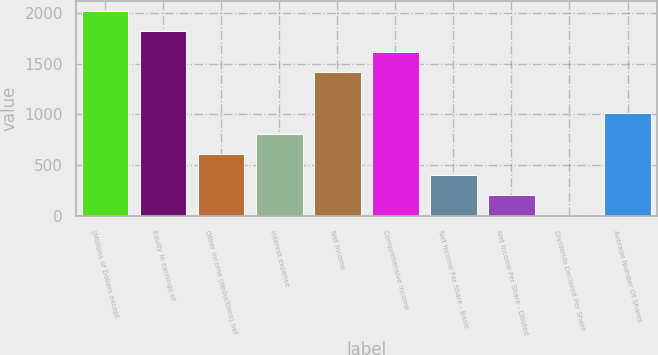<chart> <loc_0><loc_0><loc_500><loc_500><bar_chart><fcel>(Millions of Dollars except<fcel>Equity in earnings of<fcel>Other income (deductions) net<fcel>Interest expense<fcel>Net Income<fcel>Comprehensive Income<fcel>Net Income Per Share - Basic<fcel>Net Income Per Share - Diluted<fcel>Dividends Declared Per Share<fcel>Average Number Of Shares<nl><fcel>2018<fcel>1816.45<fcel>607.39<fcel>808.9<fcel>1413.43<fcel>1614.94<fcel>405.88<fcel>204.37<fcel>2.86<fcel>1010.41<nl></chart> 